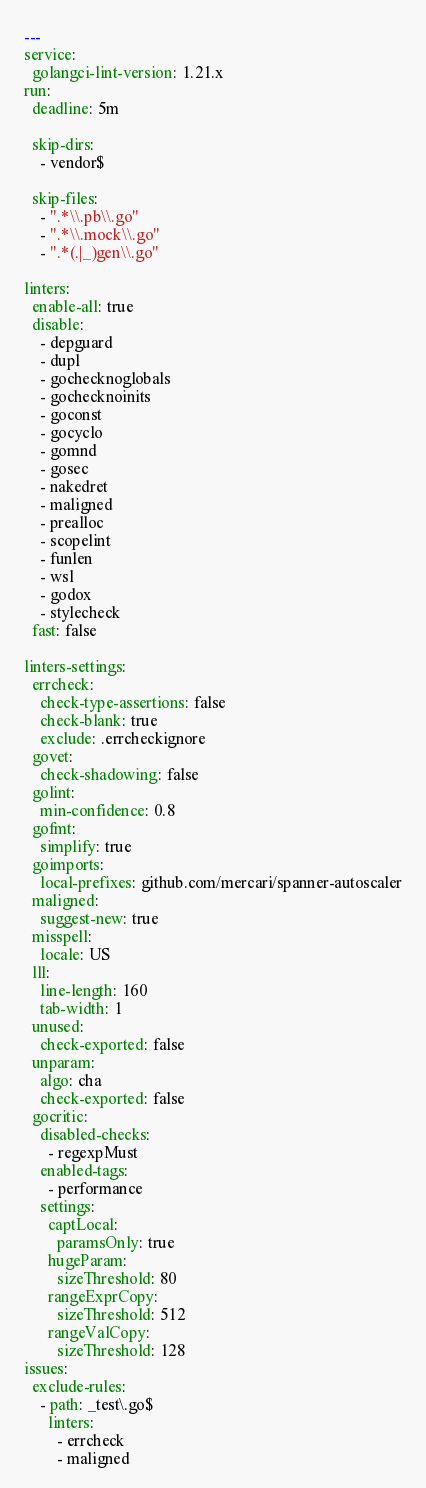Convert code to text. <code><loc_0><loc_0><loc_500><loc_500><_YAML_>---
service:
  golangci-lint-version: 1.21.x
run:
  deadline: 5m

  skip-dirs:
    - vendor$

  skip-files:
    - ".*\\.pb\\.go"
    - ".*\\.mock\\.go"
    - ".*(.|_)gen\\.go"

linters:
  enable-all: true
  disable:
    - depguard
    - dupl
    - gochecknoglobals
    - gochecknoinits
    - goconst
    - gocyclo
    - gomnd
    - gosec
    - nakedret
    - maligned
    - prealloc
    - scopelint
    - funlen
    - wsl
    - godox
    - stylecheck
  fast: false

linters-settings:
  errcheck:
    check-type-assertions: false
    check-blank: true
    exclude: .errcheckignore
  govet:
    check-shadowing: false
  golint:
    min-confidence: 0.8
  gofmt:
    simplify: true
  goimports:
    local-prefixes: github.com/mercari/spanner-autoscaler
  maligned:
    suggest-new: true
  misspell:
    locale: US
  lll:
    line-length: 160
    tab-width: 1
  unused:
    check-exported: false
  unparam:
    algo: cha
    check-exported: false
  gocritic:
    disabled-checks:
      - regexpMust
    enabled-tags:
      - performance
    settings:
      captLocal:
        paramsOnly: true
      hugeParam:
        sizeThreshold: 80
      rangeExprCopy:
        sizeThreshold: 512
      rangeValCopy:
        sizeThreshold: 128
issues:
  exclude-rules:
    - path: _test\.go$
      linters:
        - errcheck
        - maligned
</code> 